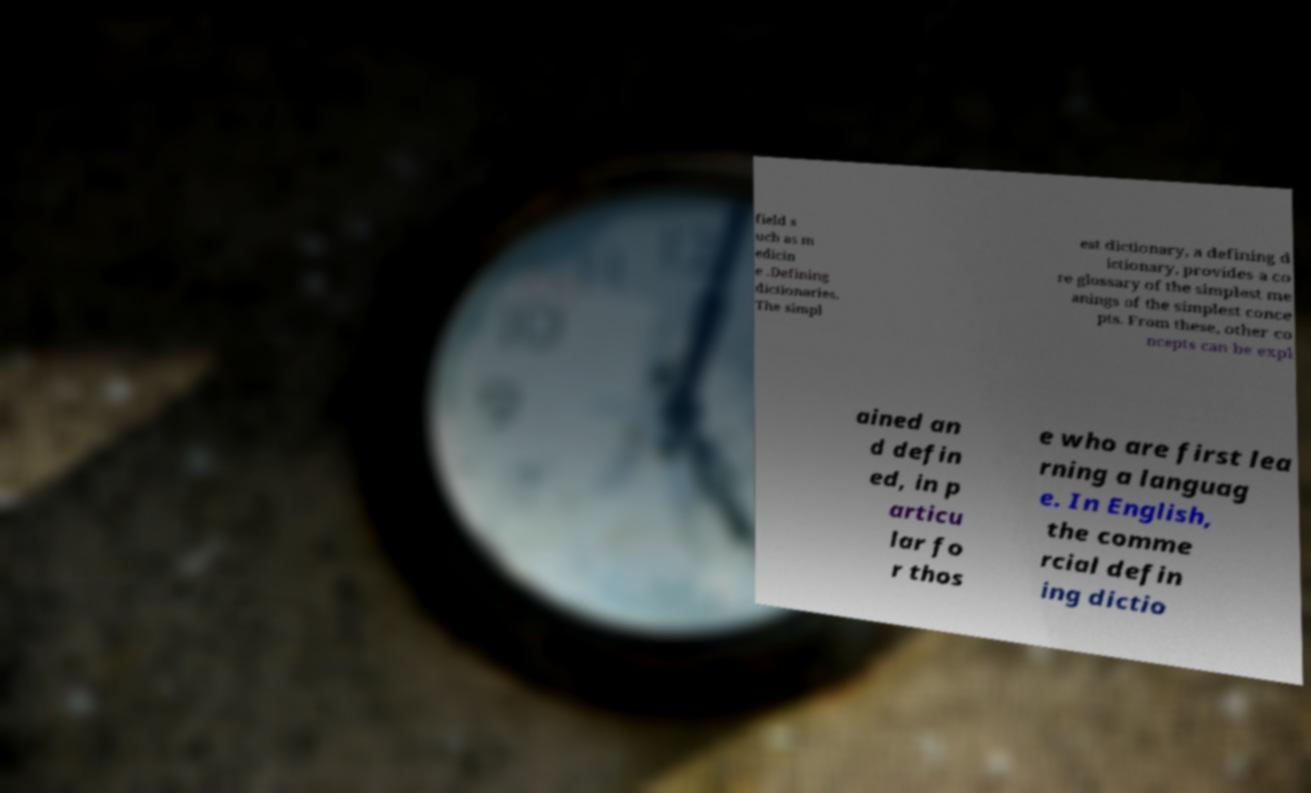Could you extract and type out the text from this image? field s uch as m edicin e .Defining dictionaries. The simpl est dictionary, a defining d ictionary, provides a co re glossary of the simplest me anings of the simplest conce pts. From these, other co ncepts can be expl ained an d defin ed, in p articu lar fo r thos e who are first lea rning a languag e. In English, the comme rcial defin ing dictio 